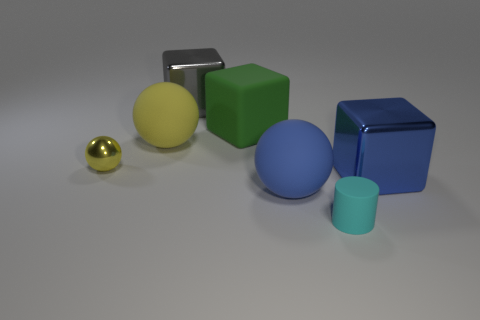Add 1 green cubes. How many objects exist? 8 Subtract all spheres. How many objects are left? 4 Add 2 small yellow metallic objects. How many small yellow metallic objects are left? 3 Add 5 big matte blocks. How many big matte blocks exist? 6 Subtract 0 green balls. How many objects are left? 7 Subtract all tiny rubber cylinders. Subtract all yellow objects. How many objects are left? 4 